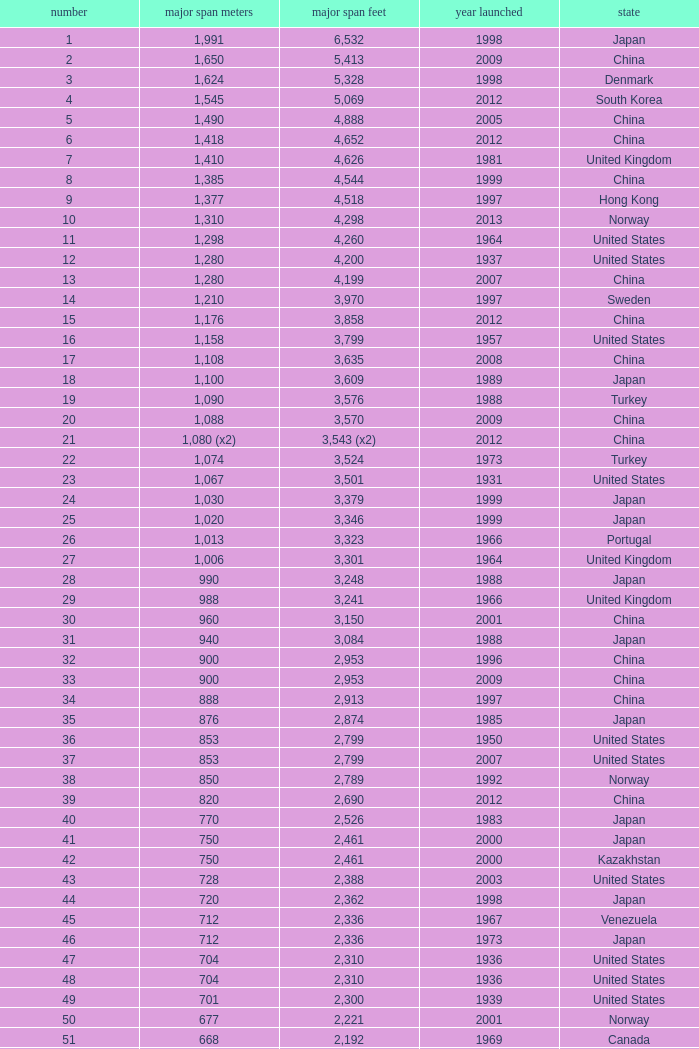What is the highest rank from the year greater than 2010 with 430 main span metres? 94.0. 